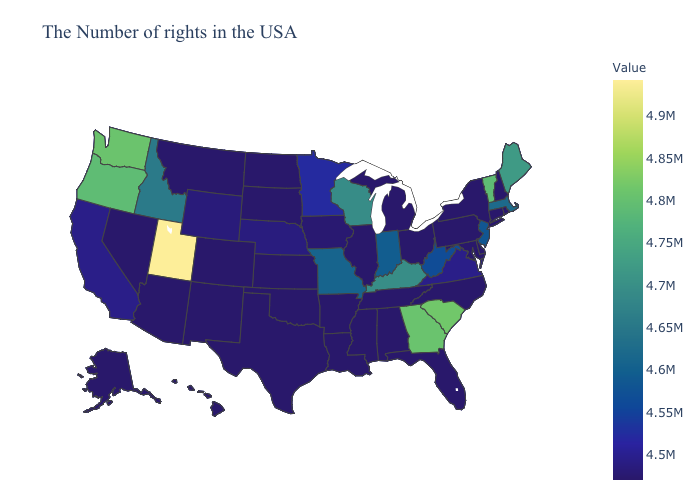Among the states that border Kansas , which have the highest value?
Give a very brief answer. Missouri. Is the legend a continuous bar?
Quick response, please. Yes. Which states have the highest value in the USA?
Quick response, please. Utah. Does Alabama have the lowest value in the USA?
Quick response, please. Yes. Which states have the lowest value in the Northeast?
Quick response, please. Rhode Island, New Hampshire, Connecticut, New York, Pennsylvania. Does Montana have the highest value in the West?
Quick response, please. No. 